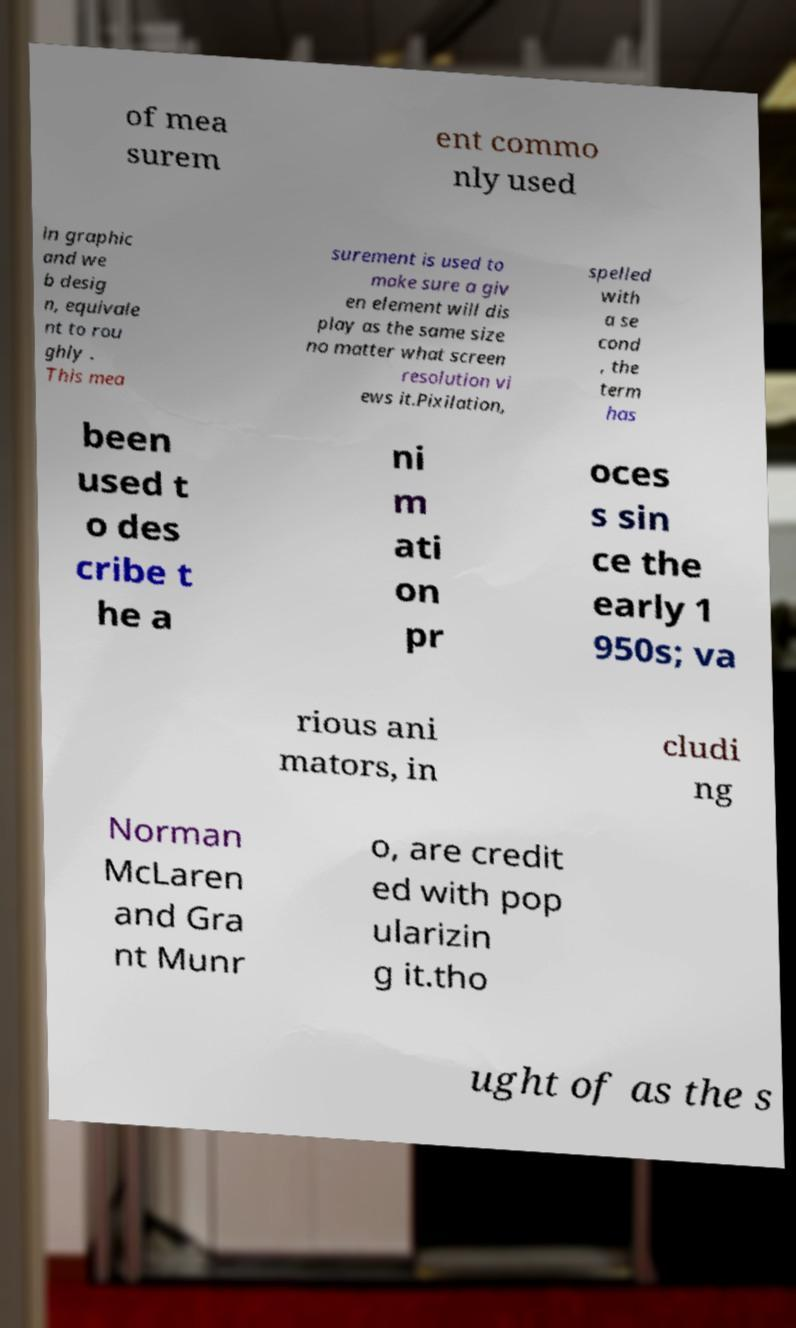There's text embedded in this image that I need extracted. Can you transcribe it verbatim? of mea surem ent commo nly used in graphic and we b desig n, equivale nt to rou ghly . This mea surement is used to make sure a giv en element will dis play as the same size no matter what screen resolution vi ews it.Pixilation, spelled with a se cond , the term has been used t o des cribe t he a ni m ati on pr oces s sin ce the early 1 950s; va rious ani mators, in cludi ng Norman McLaren and Gra nt Munr o, are credit ed with pop ularizin g it.tho ught of as the s 